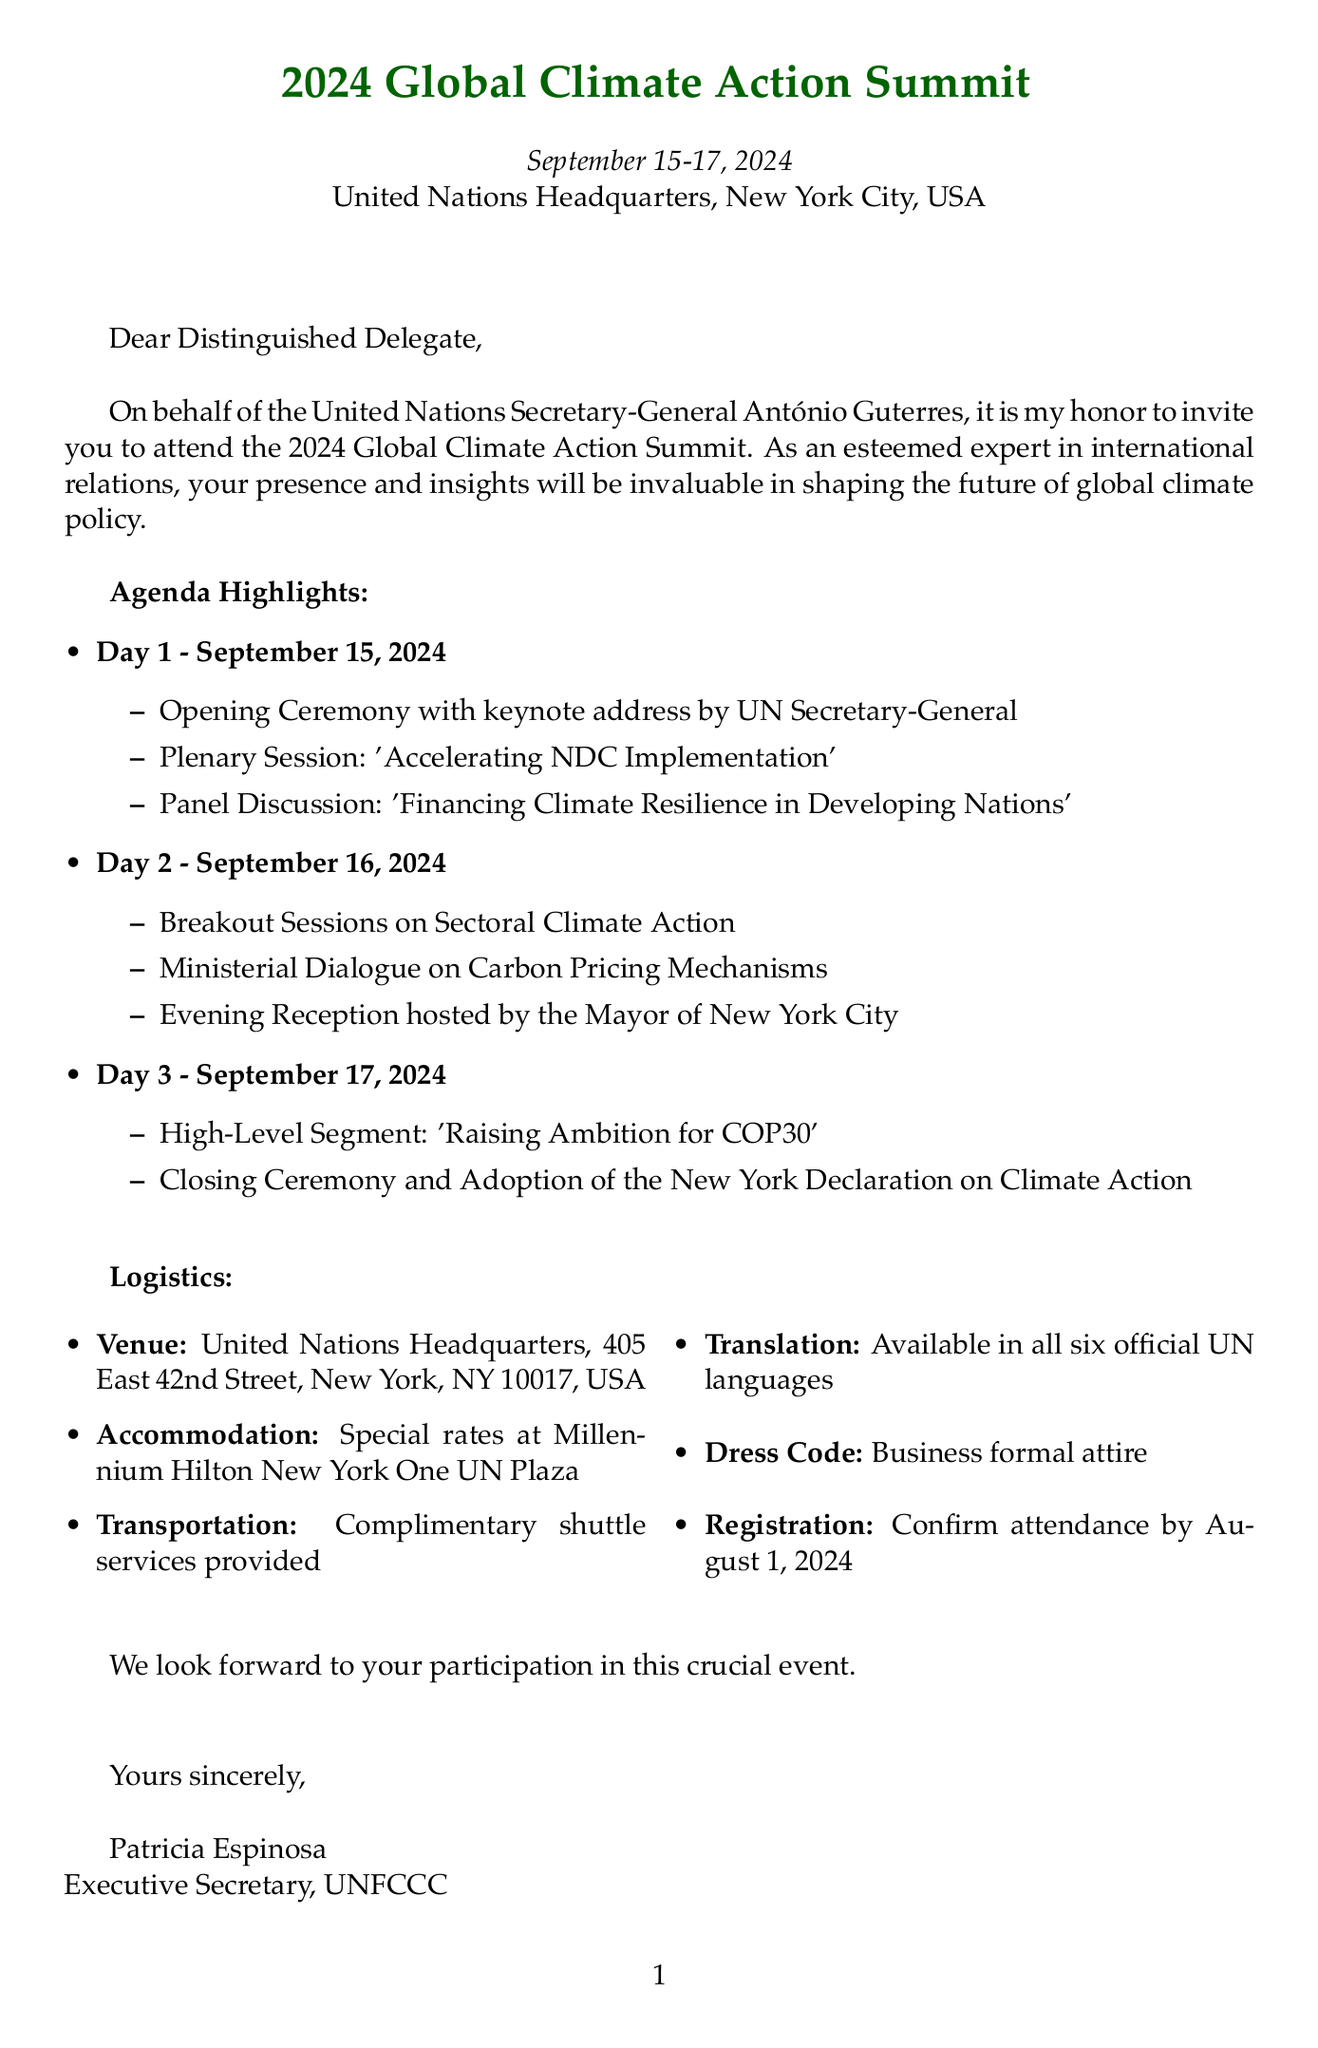What are the dates of the summit? The document specifies the event dates as September 15-17, 2024.
Answer: September 15-17, 2024 Who is the organizer of the summit? The document indicates that the summit is organized by the United Nations Framework Convention on Climate Change (UNFCCC).
Answer: United Nations Framework Convention on Climate Change (UNFCCC) What is the main theme of Day 1? The agenda for Day 1 includes events focused on accelerating NDC implementation and financing climate resilience.
Answer: Accelerating NDC Implementation What is the dress code for the summit? The document states that business formal attire is required for all sessions.
Answer: Business formal attire When should delegates confirm their attendance? The invitation specifies that attendance must be confirmed by August 1, 2024.
Answer: August 1, 2024 What type of transportation service is provided? The logistics section mentions that complimentary shuttle services will be provided between the official hotel and the UN Headquarters.
Answer: Complimentary shuttle services What is the location of the venue? The document provides the venue address as United Nations Headquarters, 405 East 42nd Street, New York, NY 10017, USA.
Answer: United Nations Headquarters, 405 East 42nd Street, New York, NY 10017, USA What additional activity is mentioned for September 14? The document states there is an exhibition on 'Climate Change Through the Lens of Art' at the Metropolitan Museum of Art.
Answer: Climate Change Through the Lens of Art Is the summit going to be a paperless event? The document confirms that the summit will be a paperless event, with materials provided digitally.
Answer: Yes 